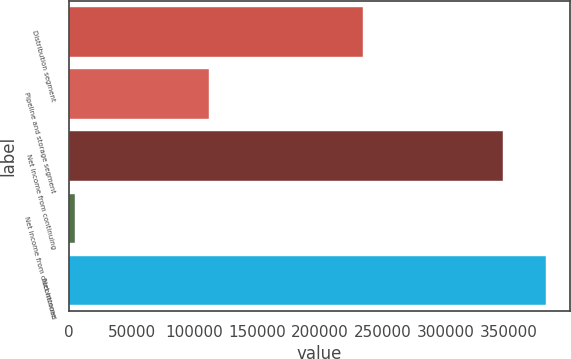Convert chart. <chart><loc_0><loc_0><loc_500><loc_500><bar_chart><fcel>Distribution segment<fcel>Pipeline and storage segment<fcel>Net income from continuing<fcel>Net income from discontinued<fcel>Net income<nl><fcel>233830<fcel>111712<fcel>345542<fcel>4562<fcel>380096<nl></chart> 